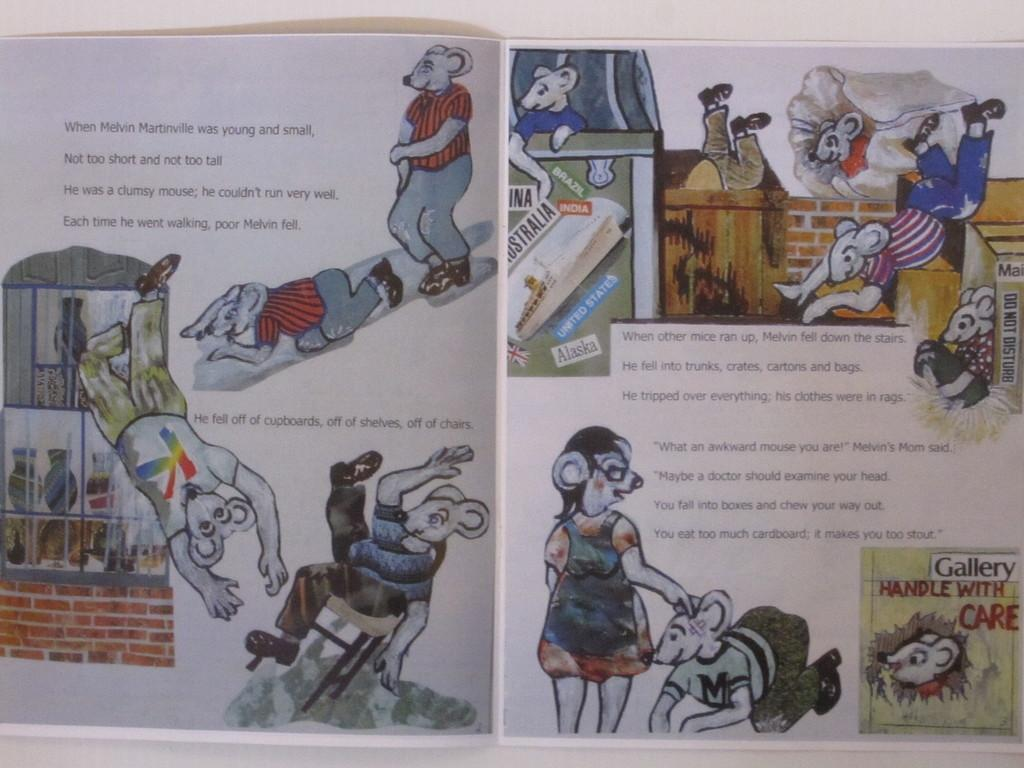<image>
Relay a brief, clear account of the picture shown. A book is opened to a page that begins with When Melvin. 